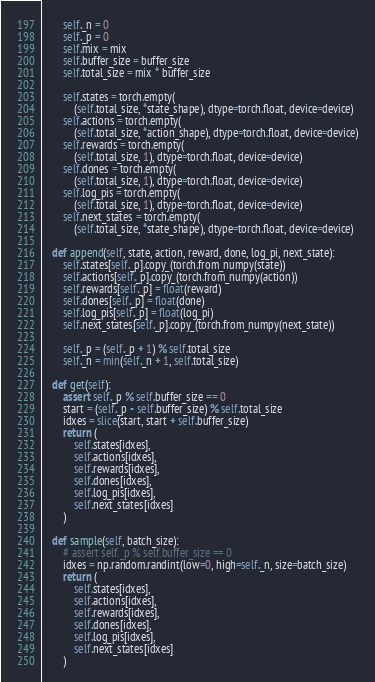Convert code to text. <code><loc_0><loc_0><loc_500><loc_500><_Python_>        self._n = 0
        self._p = 0
        self.mix = mix
        self.buffer_size = buffer_size
        self.total_size = mix * buffer_size

        self.states = torch.empty(
            (self.total_size, *state_shape), dtype=torch.float, device=device)
        self.actions = torch.empty(
            (self.total_size, *action_shape), dtype=torch.float, device=device)
        self.rewards = torch.empty(
            (self.total_size, 1), dtype=torch.float, device=device)
        self.dones = torch.empty(
            (self.total_size, 1), dtype=torch.float, device=device)
        self.log_pis = torch.empty(
            (self.total_size, 1), dtype=torch.float, device=device)
        self.next_states = torch.empty(
            (self.total_size, *state_shape), dtype=torch.float, device=device)

    def append(self, state, action, reward, done, log_pi, next_state):
        self.states[self._p].copy_(torch.from_numpy(state))
        self.actions[self._p].copy_(torch.from_numpy(action))
        self.rewards[self._p] = float(reward)
        self.dones[self._p] = float(done)
        self.log_pis[self._p] = float(log_pi)
        self.next_states[self._p].copy_(torch.from_numpy(next_state))

        self._p = (self._p + 1) % self.total_size
        self._n = min(self._n + 1, self.total_size)

    def get(self):
        assert self._p % self.buffer_size == 0
        start = (self._p - self.buffer_size) % self.total_size
        idxes = slice(start, start + self.buffer_size)
        return (
            self.states[idxes],
            self.actions[idxes],
            self.rewards[idxes],
            self.dones[idxes],
            self.log_pis[idxes],
            self.next_states[idxes]
        )

    def sample(self, batch_size):
        # assert self._p % self.buffer_size == 0
        idxes = np.random.randint(low=0, high=self._n, size=batch_size)
        return (
            self.states[idxes],
            self.actions[idxes],
            self.rewards[idxes],
            self.dones[idxes],
            self.log_pis[idxes],
            self.next_states[idxes]
        )
</code> 